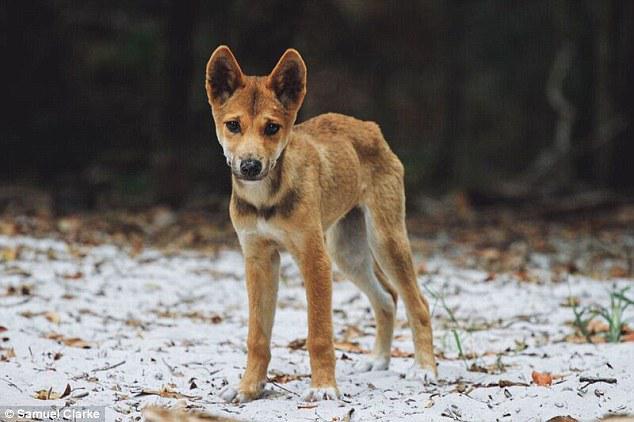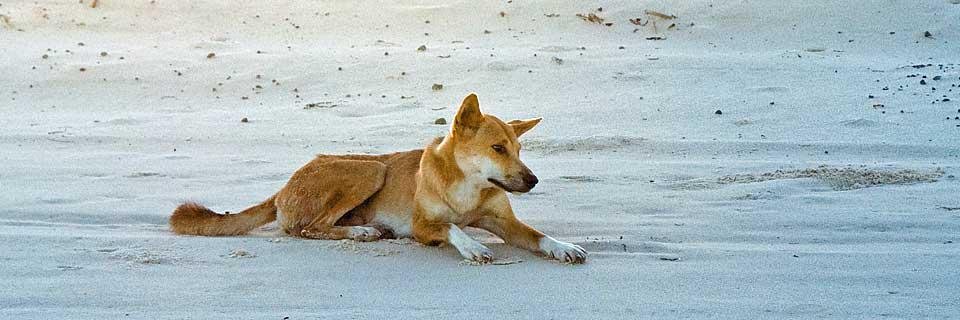The first image is the image on the left, the second image is the image on the right. Analyze the images presented: Is the assertion "There is a dog dragging a snake over sand." valid? Answer yes or no. No. 